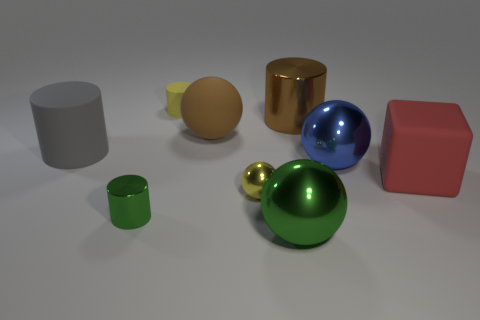Subtract 4 cylinders. How many cylinders are left? 0 Subtract all small rubber cylinders. How many cylinders are left? 3 Add 7 yellow matte cylinders. How many yellow matte cylinders exist? 8 Subtract all green spheres. How many spheres are left? 3 Subtract 1 yellow cylinders. How many objects are left? 8 Subtract all spheres. How many objects are left? 5 Subtract all yellow cylinders. Subtract all blue balls. How many cylinders are left? 3 Subtract all gray cubes. How many red cylinders are left? 0 Subtract all red objects. Subtract all large metallic spheres. How many objects are left? 6 Add 2 big red things. How many big red things are left? 3 